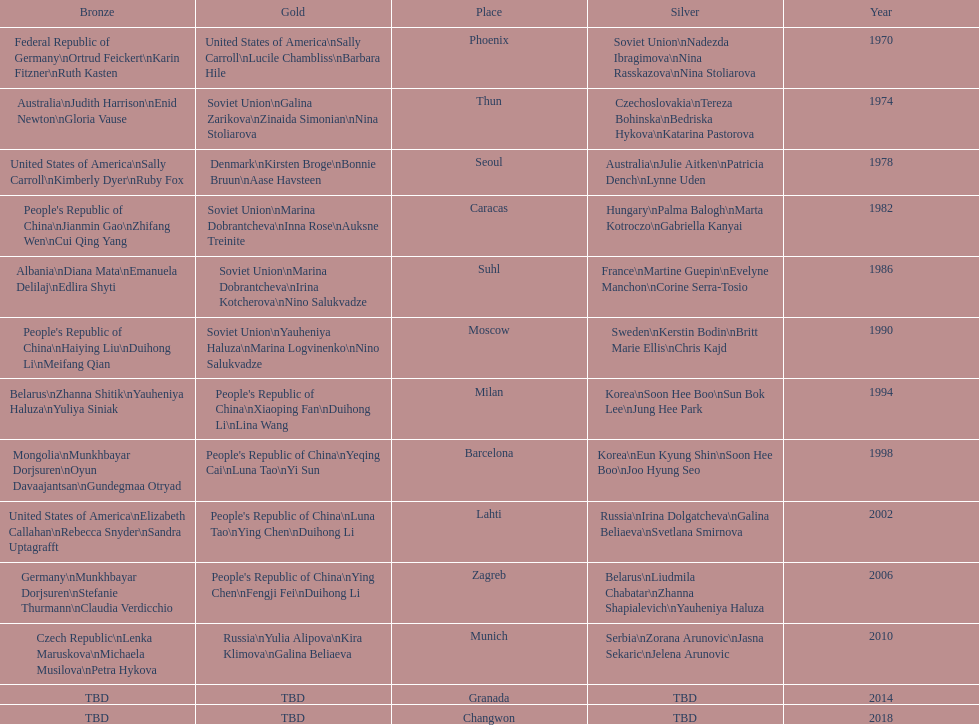Whose name is listed before bonnie bruun's in the gold column? Kirsten Broge. 